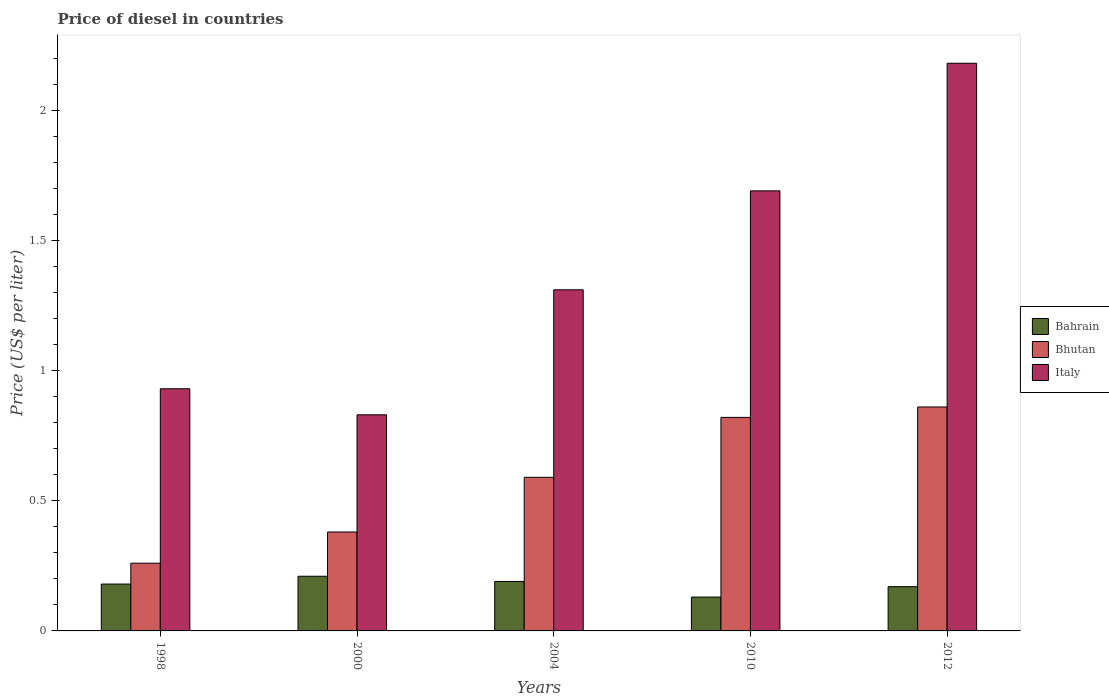Are the number of bars per tick equal to the number of legend labels?
Keep it short and to the point. Yes. How many bars are there on the 5th tick from the left?
Offer a very short reply. 3. In how many cases, is the number of bars for a given year not equal to the number of legend labels?
Offer a very short reply. 0. What is the price of diesel in Bhutan in 2010?
Keep it short and to the point. 0.82. Across all years, what is the maximum price of diesel in Bhutan?
Give a very brief answer. 0.86. Across all years, what is the minimum price of diesel in Bahrain?
Give a very brief answer. 0.13. In which year was the price of diesel in Italy maximum?
Offer a terse response. 2012. In which year was the price of diesel in Bhutan minimum?
Provide a short and direct response. 1998. What is the total price of diesel in Bhutan in the graph?
Provide a short and direct response. 2.91. What is the difference between the price of diesel in Italy in 2000 and that in 2010?
Provide a short and direct response. -0.86. What is the difference between the price of diesel in Bahrain in 2000 and the price of diesel in Bhutan in 2010?
Offer a very short reply. -0.61. What is the average price of diesel in Bahrain per year?
Your response must be concise. 0.18. In the year 2000, what is the difference between the price of diesel in Bhutan and price of diesel in Bahrain?
Provide a short and direct response. 0.17. What is the ratio of the price of diesel in Bhutan in 1998 to that in 2000?
Offer a very short reply. 0.68. Is the difference between the price of diesel in Bhutan in 2004 and 2012 greater than the difference between the price of diesel in Bahrain in 2004 and 2012?
Ensure brevity in your answer.  No. What is the difference between the highest and the second highest price of diesel in Bhutan?
Ensure brevity in your answer.  0.04. What does the 3rd bar from the left in 2012 represents?
Your answer should be compact. Italy. What does the 2nd bar from the right in 2000 represents?
Offer a very short reply. Bhutan. How many bars are there?
Offer a very short reply. 15. How many years are there in the graph?
Offer a terse response. 5. Are the values on the major ticks of Y-axis written in scientific E-notation?
Provide a succinct answer. No. Does the graph contain grids?
Offer a very short reply. No. Where does the legend appear in the graph?
Give a very brief answer. Center right. What is the title of the graph?
Offer a terse response. Price of diesel in countries. What is the label or title of the Y-axis?
Offer a very short reply. Price (US$ per liter). What is the Price (US$ per liter) in Bahrain in 1998?
Provide a succinct answer. 0.18. What is the Price (US$ per liter) in Bhutan in 1998?
Keep it short and to the point. 0.26. What is the Price (US$ per liter) of Italy in 1998?
Your response must be concise. 0.93. What is the Price (US$ per liter) in Bahrain in 2000?
Offer a very short reply. 0.21. What is the Price (US$ per liter) of Bhutan in 2000?
Provide a succinct answer. 0.38. What is the Price (US$ per liter) of Italy in 2000?
Make the answer very short. 0.83. What is the Price (US$ per liter) in Bahrain in 2004?
Ensure brevity in your answer.  0.19. What is the Price (US$ per liter) in Bhutan in 2004?
Ensure brevity in your answer.  0.59. What is the Price (US$ per liter) in Italy in 2004?
Your answer should be compact. 1.31. What is the Price (US$ per liter) of Bahrain in 2010?
Provide a short and direct response. 0.13. What is the Price (US$ per liter) in Bhutan in 2010?
Your answer should be compact. 0.82. What is the Price (US$ per liter) of Italy in 2010?
Your answer should be very brief. 1.69. What is the Price (US$ per liter) of Bahrain in 2012?
Your response must be concise. 0.17. What is the Price (US$ per liter) of Bhutan in 2012?
Keep it short and to the point. 0.86. What is the Price (US$ per liter) of Italy in 2012?
Your answer should be very brief. 2.18. Across all years, what is the maximum Price (US$ per liter) in Bahrain?
Make the answer very short. 0.21. Across all years, what is the maximum Price (US$ per liter) of Bhutan?
Your answer should be very brief. 0.86. Across all years, what is the maximum Price (US$ per liter) of Italy?
Ensure brevity in your answer.  2.18. Across all years, what is the minimum Price (US$ per liter) in Bahrain?
Provide a short and direct response. 0.13. Across all years, what is the minimum Price (US$ per liter) of Bhutan?
Your response must be concise. 0.26. Across all years, what is the minimum Price (US$ per liter) in Italy?
Your answer should be very brief. 0.83. What is the total Price (US$ per liter) in Bahrain in the graph?
Provide a succinct answer. 0.88. What is the total Price (US$ per liter) of Bhutan in the graph?
Your response must be concise. 2.91. What is the total Price (US$ per liter) of Italy in the graph?
Give a very brief answer. 6.94. What is the difference between the Price (US$ per liter) of Bahrain in 1998 and that in 2000?
Make the answer very short. -0.03. What is the difference between the Price (US$ per liter) of Bhutan in 1998 and that in 2000?
Make the answer very short. -0.12. What is the difference between the Price (US$ per liter) in Italy in 1998 and that in 2000?
Provide a succinct answer. 0.1. What is the difference between the Price (US$ per liter) in Bahrain in 1998 and that in 2004?
Provide a succinct answer. -0.01. What is the difference between the Price (US$ per liter) of Bhutan in 1998 and that in 2004?
Make the answer very short. -0.33. What is the difference between the Price (US$ per liter) in Italy in 1998 and that in 2004?
Keep it short and to the point. -0.38. What is the difference between the Price (US$ per liter) of Bhutan in 1998 and that in 2010?
Your answer should be very brief. -0.56. What is the difference between the Price (US$ per liter) of Italy in 1998 and that in 2010?
Provide a succinct answer. -0.76. What is the difference between the Price (US$ per liter) of Bhutan in 1998 and that in 2012?
Provide a short and direct response. -0.6. What is the difference between the Price (US$ per liter) of Italy in 1998 and that in 2012?
Give a very brief answer. -1.25. What is the difference between the Price (US$ per liter) of Bhutan in 2000 and that in 2004?
Offer a terse response. -0.21. What is the difference between the Price (US$ per liter) of Italy in 2000 and that in 2004?
Offer a terse response. -0.48. What is the difference between the Price (US$ per liter) in Bhutan in 2000 and that in 2010?
Offer a terse response. -0.44. What is the difference between the Price (US$ per liter) in Italy in 2000 and that in 2010?
Provide a short and direct response. -0.86. What is the difference between the Price (US$ per liter) in Bahrain in 2000 and that in 2012?
Provide a short and direct response. 0.04. What is the difference between the Price (US$ per liter) of Bhutan in 2000 and that in 2012?
Your answer should be compact. -0.48. What is the difference between the Price (US$ per liter) of Italy in 2000 and that in 2012?
Your response must be concise. -1.35. What is the difference between the Price (US$ per liter) in Bhutan in 2004 and that in 2010?
Give a very brief answer. -0.23. What is the difference between the Price (US$ per liter) in Italy in 2004 and that in 2010?
Keep it short and to the point. -0.38. What is the difference between the Price (US$ per liter) of Bhutan in 2004 and that in 2012?
Your answer should be very brief. -0.27. What is the difference between the Price (US$ per liter) in Italy in 2004 and that in 2012?
Offer a very short reply. -0.87. What is the difference between the Price (US$ per liter) of Bahrain in 2010 and that in 2012?
Provide a short and direct response. -0.04. What is the difference between the Price (US$ per liter) of Bhutan in 2010 and that in 2012?
Your answer should be compact. -0.04. What is the difference between the Price (US$ per liter) of Italy in 2010 and that in 2012?
Your answer should be compact. -0.49. What is the difference between the Price (US$ per liter) of Bahrain in 1998 and the Price (US$ per liter) of Bhutan in 2000?
Your response must be concise. -0.2. What is the difference between the Price (US$ per liter) of Bahrain in 1998 and the Price (US$ per liter) of Italy in 2000?
Give a very brief answer. -0.65. What is the difference between the Price (US$ per liter) of Bhutan in 1998 and the Price (US$ per liter) of Italy in 2000?
Your response must be concise. -0.57. What is the difference between the Price (US$ per liter) of Bahrain in 1998 and the Price (US$ per liter) of Bhutan in 2004?
Your answer should be compact. -0.41. What is the difference between the Price (US$ per liter) of Bahrain in 1998 and the Price (US$ per liter) of Italy in 2004?
Your answer should be compact. -1.13. What is the difference between the Price (US$ per liter) of Bhutan in 1998 and the Price (US$ per liter) of Italy in 2004?
Give a very brief answer. -1.05. What is the difference between the Price (US$ per liter) in Bahrain in 1998 and the Price (US$ per liter) in Bhutan in 2010?
Keep it short and to the point. -0.64. What is the difference between the Price (US$ per liter) in Bahrain in 1998 and the Price (US$ per liter) in Italy in 2010?
Make the answer very short. -1.51. What is the difference between the Price (US$ per liter) of Bhutan in 1998 and the Price (US$ per liter) of Italy in 2010?
Your answer should be very brief. -1.43. What is the difference between the Price (US$ per liter) in Bahrain in 1998 and the Price (US$ per liter) in Bhutan in 2012?
Your response must be concise. -0.68. What is the difference between the Price (US$ per liter) in Bahrain in 1998 and the Price (US$ per liter) in Italy in 2012?
Keep it short and to the point. -2. What is the difference between the Price (US$ per liter) of Bhutan in 1998 and the Price (US$ per liter) of Italy in 2012?
Give a very brief answer. -1.92. What is the difference between the Price (US$ per liter) of Bahrain in 2000 and the Price (US$ per liter) of Bhutan in 2004?
Your answer should be very brief. -0.38. What is the difference between the Price (US$ per liter) in Bahrain in 2000 and the Price (US$ per liter) in Italy in 2004?
Give a very brief answer. -1.1. What is the difference between the Price (US$ per liter) of Bhutan in 2000 and the Price (US$ per liter) of Italy in 2004?
Make the answer very short. -0.93. What is the difference between the Price (US$ per liter) of Bahrain in 2000 and the Price (US$ per liter) of Bhutan in 2010?
Give a very brief answer. -0.61. What is the difference between the Price (US$ per liter) of Bahrain in 2000 and the Price (US$ per liter) of Italy in 2010?
Your response must be concise. -1.48. What is the difference between the Price (US$ per liter) of Bhutan in 2000 and the Price (US$ per liter) of Italy in 2010?
Your response must be concise. -1.31. What is the difference between the Price (US$ per liter) of Bahrain in 2000 and the Price (US$ per liter) of Bhutan in 2012?
Offer a terse response. -0.65. What is the difference between the Price (US$ per liter) in Bahrain in 2000 and the Price (US$ per liter) in Italy in 2012?
Offer a terse response. -1.97. What is the difference between the Price (US$ per liter) of Bahrain in 2004 and the Price (US$ per liter) of Bhutan in 2010?
Your answer should be compact. -0.63. What is the difference between the Price (US$ per liter) in Bahrain in 2004 and the Price (US$ per liter) in Italy in 2010?
Offer a terse response. -1.5. What is the difference between the Price (US$ per liter) in Bahrain in 2004 and the Price (US$ per liter) in Bhutan in 2012?
Provide a succinct answer. -0.67. What is the difference between the Price (US$ per liter) of Bahrain in 2004 and the Price (US$ per liter) of Italy in 2012?
Make the answer very short. -1.99. What is the difference between the Price (US$ per liter) in Bhutan in 2004 and the Price (US$ per liter) in Italy in 2012?
Your answer should be very brief. -1.59. What is the difference between the Price (US$ per liter) of Bahrain in 2010 and the Price (US$ per liter) of Bhutan in 2012?
Your answer should be very brief. -0.73. What is the difference between the Price (US$ per liter) of Bahrain in 2010 and the Price (US$ per liter) of Italy in 2012?
Your answer should be compact. -2.05. What is the difference between the Price (US$ per liter) of Bhutan in 2010 and the Price (US$ per liter) of Italy in 2012?
Give a very brief answer. -1.36. What is the average Price (US$ per liter) of Bahrain per year?
Provide a short and direct response. 0.18. What is the average Price (US$ per liter) of Bhutan per year?
Make the answer very short. 0.58. What is the average Price (US$ per liter) of Italy per year?
Keep it short and to the point. 1.39. In the year 1998, what is the difference between the Price (US$ per liter) in Bahrain and Price (US$ per liter) in Bhutan?
Offer a terse response. -0.08. In the year 1998, what is the difference between the Price (US$ per liter) in Bahrain and Price (US$ per liter) in Italy?
Keep it short and to the point. -0.75. In the year 1998, what is the difference between the Price (US$ per liter) of Bhutan and Price (US$ per liter) of Italy?
Provide a short and direct response. -0.67. In the year 2000, what is the difference between the Price (US$ per liter) in Bahrain and Price (US$ per liter) in Bhutan?
Give a very brief answer. -0.17. In the year 2000, what is the difference between the Price (US$ per liter) in Bahrain and Price (US$ per liter) in Italy?
Offer a very short reply. -0.62. In the year 2000, what is the difference between the Price (US$ per liter) in Bhutan and Price (US$ per liter) in Italy?
Your response must be concise. -0.45. In the year 2004, what is the difference between the Price (US$ per liter) of Bahrain and Price (US$ per liter) of Italy?
Provide a short and direct response. -1.12. In the year 2004, what is the difference between the Price (US$ per liter) in Bhutan and Price (US$ per liter) in Italy?
Offer a terse response. -0.72. In the year 2010, what is the difference between the Price (US$ per liter) in Bahrain and Price (US$ per liter) in Bhutan?
Offer a very short reply. -0.69. In the year 2010, what is the difference between the Price (US$ per liter) of Bahrain and Price (US$ per liter) of Italy?
Keep it short and to the point. -1.56. In the year 2010, what is the difference between the Price (US$ per liter) of Bhutan and Price (US$ per liter) of Italy?
Keep it short and to the point. -0.87. In the year 2012, what is the difference between the Price (US$ per liter) in Bahrain and Price (US$ per liter) in Bhutan?
Keep it short and to the point. -0.69. In the year 2012, what is the difference between the Price (US$ per liter) in Bahrain and Price (US$ per liter) in Italy?
Provide a short and direct response. -2.01. In the year 2012, what is the difference between the Price (US$ per liter) of Bhutan and Price (US$ per liter) of Italy?
Your answer should be compact. -1.32. What is the ratio of the Price (US$ per liter) of Bhutan in 1998 to that in 2000?
Ensure brevity in your answer.  0.68. What is the ratio of the Price (US$ per liter) in Italy in 1998 to that in 2000?
Your answer should be very brief. 1.12. What is the ratio of the Price (US$ per liter) in Bhutan in 1998 to that in 2004?
Make the answer very short. 0.44. What is the ratio of the Price (US$ per liter) of Italy in 1998 to that in 2004?
Offer a terse response. 0.71. What is the ratio of the Price (US$ per liter) in Bahrain in 1998 to that in 2010?
Offer a very short reply. 1.38. What is the ratio of the Price (US$ per liter) in Bhutan in 1998 to that in 2010?
Your response must be concise. 0.32. What is the ratio of the Price (US$ per liter) in Italy in 1998 to that in 2010?
Your answer should be compact. 0.55. What is the ratio of the Price (US$ per liter) in Bahrain in 1998 to that in 2012?
Offer a very short reply. 1.06. What is the ratio of the Price (US$ per liter) of Bhutan in 1998 to that in 2012?
Your answer should be compact. 0.3. What is the ratio of the Price (US$ per liter) of Italy in 1998 to that in 2012?
Provide a succinct answer. 0.43. What is the ratio of the Price (US$ per liter) in Bahrain in 2000 to that in 2004?
Keep it short and to the point. 1.11. What is the ratio of the Price (US$ per liter) of Bhutan in 2000 to that in 2004?
Offer a terse response. 0.64. What is the ratio of the Price (US$ per liter) in Italy in 2000 to that in 2004?
Ensure brevity in your answer.  0.63. What is the ratio of the Price (US$ per liter) in Bahrain in 2000 to that in 2010?
Your answer should be very brief. 1.62. What is the ratio of the Price (US$ per liter) of Bhutan in 2000 to that in 2010?
Make the answer very short. 0.46. What is the ratio of the Price (US$ per liter) of Italy in 2000 to that in 2010?
Offer a very short reply. 0.49. What is the ratio of the Price (US$ per liter) in Bahrain in 2000 to that in 2012?
Ensure brevity in your answer.  1.24. What is the ratio of the Price (US$ per liter) in Bhutan in 2000 to that in 2012?
Your answer should be compact. 0.44. What is the ratio of the Price (US$ per liter) in Italy in 2000 to that in 2012?
Provide a short and direct response. 0.38. What is the ratio of the Price (US$ per liter) in Bahrain in 2004 to that in 2010?
Keep it short and to the point. 1.46. What is the ratio of the Price (US$ per liter) of Bhutan in 2004 to that in 2010?
Ensure brevity in your answer.  0.72. What is the ratio of the Price (US$ per liter) in Italy in 2004 to that in 2010?
Provide a succinct answer. 0.78. What is the ratio of the Price (US$ per liter) in Bahrain in 2004 to that in 2012?
Your response must be concise. 1.12. What is the ratio of the Price (US$ per liter) in Bhutan in 2004 to that in 2012?
Provide a succinct answer. 0.69. What is the ratio of the Price (US$ per liter) of Italy in 2004 to that in 2012?
Provide a succinct answer. 0.6. What is the ratio of the Price (US$ per liter) in Bahrain in 2010 to that in 2012?
Ensure brevity in your answer.  0.76. What is the ratio of the Price (US$ per liter) in Bhutan in 2010 to that in 2012?
Offer a terse response. 0.95. What is the ratio of the Price (US$ per liter) of Italy in 2010 to that in 2012?
Your answer should be very brief. 0.78. What is the difference between the highest and the second highest Price (US$ per liter) in Bahrain?
Provide a short and direct response. 0.02. What is the difference between the highest and the second highest Price (US$ per liter) of Bhutan?
Give a very brief answer. 0.04. What is the difference between the highest and the second highest Price (US$ per liter) of Italy?
Keep it short and to the point. 0.49. What is the difference between the highest and the lowest Price (US$ per liter) in Bahrain?
Provide a succinct answer. 0.08. What is the difference between the highest and the lowest Price (US$ per liter) of Italy?
Keep it short and to the point. 1.35. 